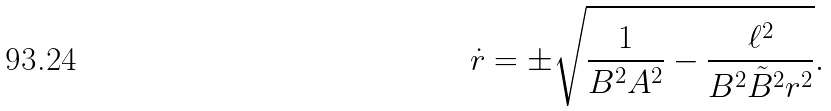<formula> <loc_0><loc_0><loc_500><loc_500>\dot { r } = \pm \sqrt { { \frac { 1 } { B ^ { 2 } A ^ { 2 } } } - { \frac { \ell ^ { 2 } } { B ^ { 2 } \tilde { B } ^ { 2 } r ^ { 2 } } } } .</formula> 